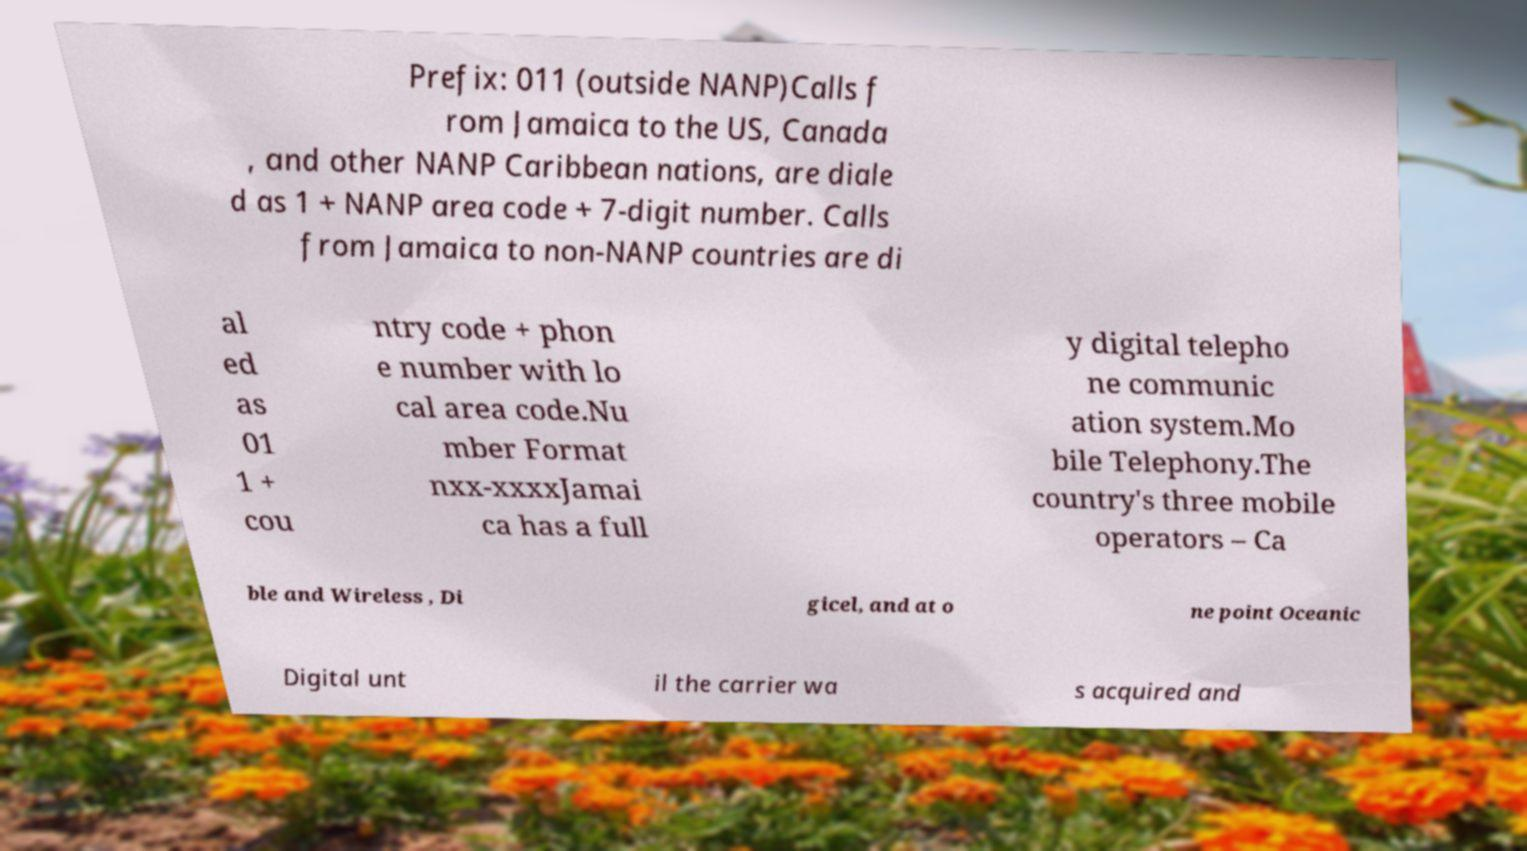For documentation purposes, I need the text within this image transcribed. Could you provide that? Prefix: 011 (outside NANP)Calls f rom Jamaica to the US, Canada , and other NANP Caribbean nations, are diale d as 1 + NANP area code + 7-digit number. Calls from Jamaica to non-NANP countries are di al ed as 01 1 + cou ntry code + phon e number with lo cal area code.Nu mber Format nxx-xxxxJamai ca has a full y digital telepho ne communic ation system.Mo bile Telephony.The country's three mobile operators – Ca ble and Wireless , Di gicel, and at o ne point Oceanic Digital unt il the carrier wa s acquired and 